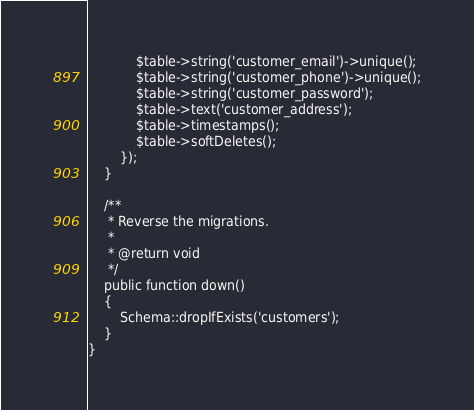<code> <loc_0><loc_0><loc_500><loc_500><_PHP_>            $table->string('customer_email')->unique();
            $table->string('customer_phone')->unique();
            $table->string('customer_password');
            $table->text('customer_address');
            $table->timestamps();
            $table->softDeletes();
        });
    }

    /**
     * Reverse the migrations.
     *
     * @return void
     */
    public function down()
    {
        Schema::dropIfExists('customers');
    }
}
</code> 